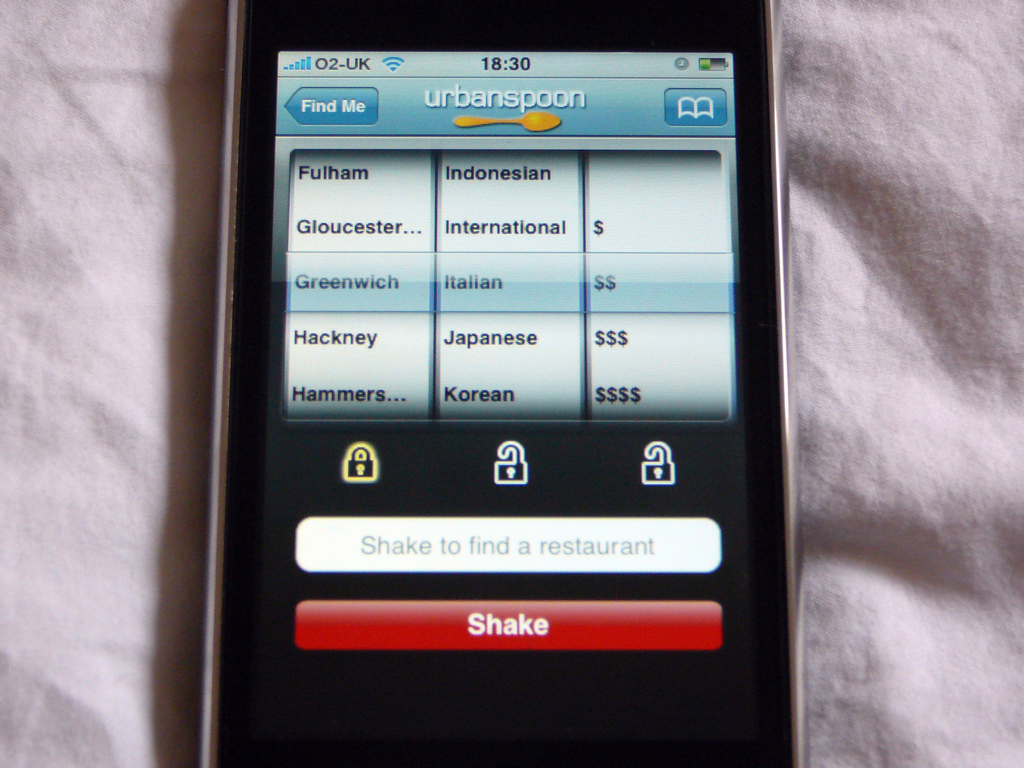What do you see happening in this image?
 The image captures a moment of interaction with the Urbanspoon app on a mobile phone. The app is currently displaying a search interface where the user can find restaurants based on location and cuisine. Locations such as Fulham, Gloucester, Greenwich, Hackney, and Hammersmith are visible, along with cuisines like Indonesian, International, Italian, Japanese, and Korean. Each cuisine is accompanied by a price range, represented by dollar signs. An intriguing feature of the app is that it allows the user to shake their phone to find a restaurant at random. The time displayed on the phone is 18:30 and the carrier is O2-UK, indicating that the user might be located in the United Kingdom. 